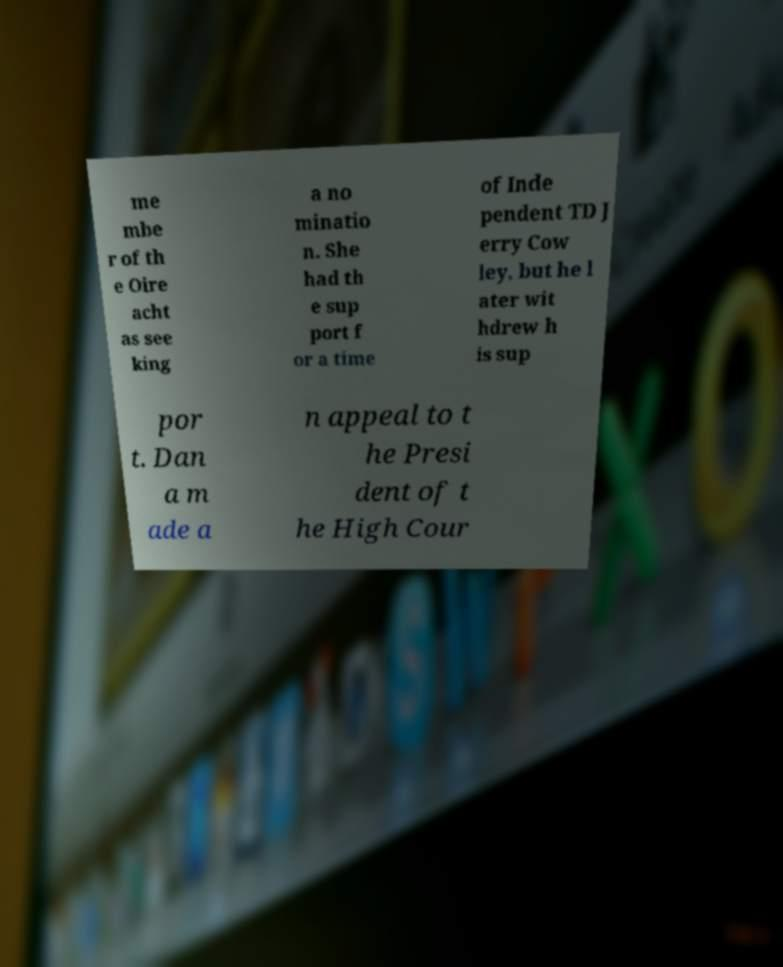Could you extract and type out the text from this image? me mbe r of th e Oire acht as see king a no minatio n. She had th e sup port f or a time of Inde pendent TD J erry Cow ley, but he l ater wit hdrew h is sup por t. Dan a m ade a n appeal to t he Presi dent of t he High Cour 